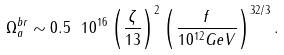Convert formula to latex. <formula><loc_0><loc_0><loc_500><loc_500>\Omega ^ { b r } _ { a } \sim 0 . 5 \ 1 0 ^ { 1 6 } \left ( \frac { \zeta } { 1 3 } \right ) ^ { 2 } \left ( \frac { f } { 1 0 ^ { 1 2 } G e V } \right ) ^ { 3 2 / 3 } .</formula> 